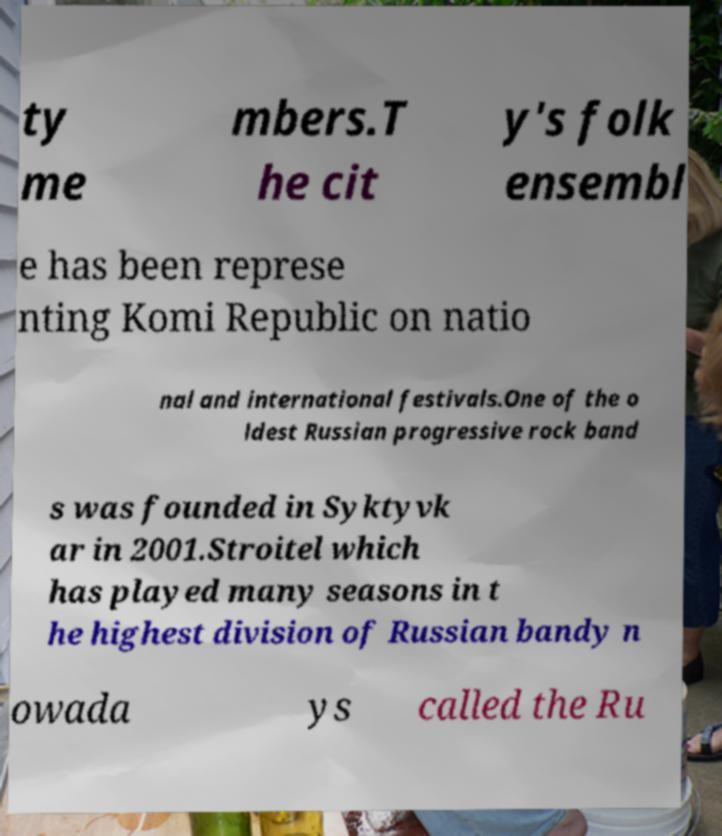Please read and relay the text visible in this image. What does it say? ty me mbers.T he cit y's folk ensembl e has been represe nting Komi Republic on natio nal and international festivals.One of the o ldest Russian progressive rock band s was founded in Syktyvk ar in 2001.Stroitel which has played many seasons in t he highest division of Russian bandy n owada ys called the Ru 